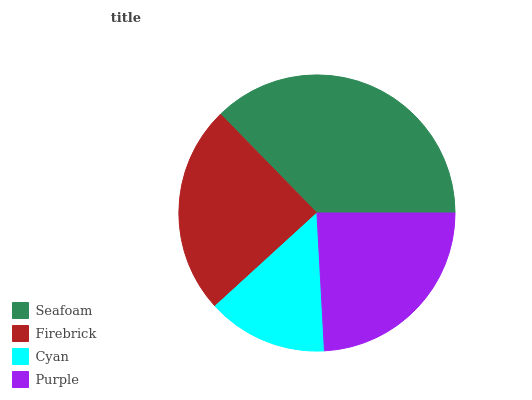Is Cyan the minimum?
Answer yes or no. Yes. Is Seafoam the maximum?
Answer yes or no. Yes. Is Firebrick the minimum?
Answer yes or no. No. Is Firebrick the maximum?
Answer yes or no. No. Is Seafoam greater than Firebrick?
Answer yes or no. Yes. Is Firebrick less than Seafoam?
Answer yes or no. Yes. Is Firebrick greater than Seafoam?
Answer yes or no. No. Is Seafoam less than Firebrick?
Answer yes or no. No. Is Firebrick the high median?
Answer yes or no. Yes. Is Purple the low median?
Answer yes or no. Yes. Is Seafoam the high median?
Answer yes or no. No. Is Firebrick the low median?
Answer yes or no. No. 